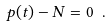Convert formula to latex. <formula><loc_0><loc_0><loc_500><loc_500>p ( t ) - N = 0 \ .</formula> 